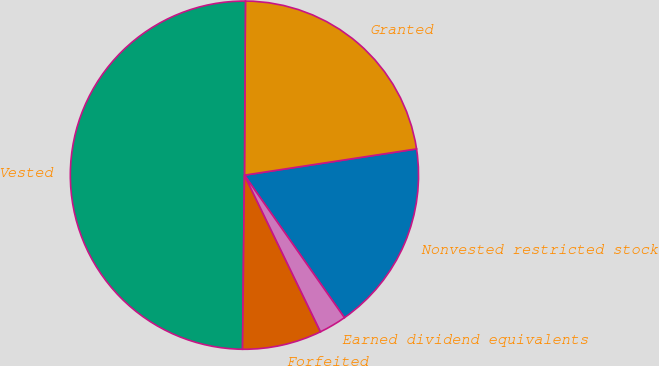Convert chart to OTSL. <chart><loc_0><loc_0><loc_500><loc_500><pie_chart><fcel>Nonvested restricted stock<fcel>Granted<fcel>Vested<fcel>Forfeited<fcel>Earned dividend equivalents<nl><fcel>17.67%<fcel>22.5%<fcel>49.92%<fcel>7.37%<fcel>2.54%<nl></chart> 